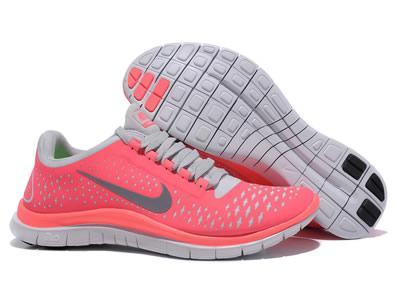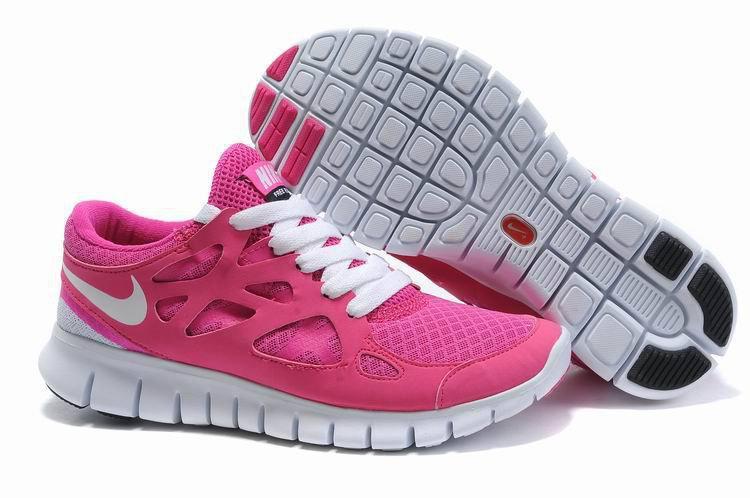The first image is the image on the left, the second image is the image on the right. Evaluate the accuracy of this statement regarding the images: "The bottom of a shoe sole is displayed facing the camera in each image.". Is it true? Answer yes or no. Yes. The first image is the image on the left, the second image is the image on the right. For the images shown, is this caption "Each image shows one laced-up shoe with a logo in profile, while a second shoe is angled behind it with the sole displayed." true? Answer yes or no. Yes. 